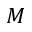Convert formula to latex. <formula><loc_0><loc_0><loc_500><loc_500>M</formula> 